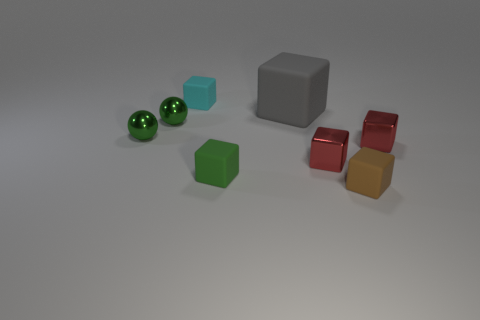How many metallic balls are in front of the big gray thing?
Your response must be concise. 2. Do the tiny thing that is behind the large gray matte thing and the brown block have the same material?
Your answer should be very brief. Yes. What color is the other big rubber object that is the same shape as the cyan object?
Offer a very short reply. Gray. What is the shape of the small green rubber object?
Give a very brief answer. Cube. How many things are either cyan shiny cubes or tiny cyan rubber cubes?
Provide a short and direct response. 1. Does the small block that is to the right of the tiny brown cube have the same color as the large matte thing left of the brown block?
Your answer should be very brief. No. What number of other objects are there of the same shape as the tiny cyan rubber thing?
Provide a short and direct response. 5. Are any small gray metallic cylinders visible?
Provide a succinct answer. No. How many things are tiny purple spheres or tiny matte cubes left of the gray thing?
Provide a short and direct response. 2. Do the green object to the right of the cyan thing and the small cyan rubber object have the same size?
Your answer should be very brief. Yes. 